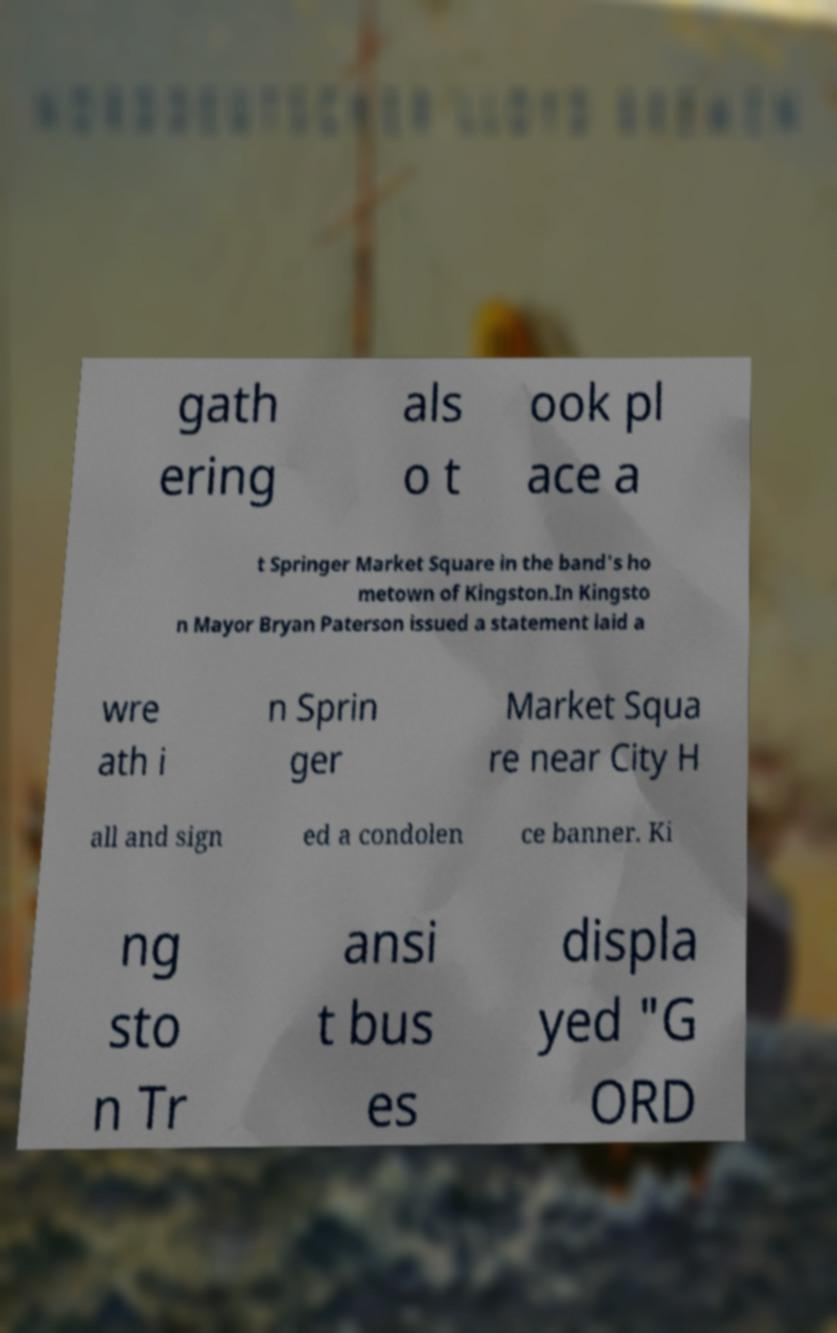Could you extract and type out the text from this image? gath ering als o t ook pl ace a t Springer Market Square in the band's ho metown of Kingston.In Kingsto n Mayor Bryan Paterson issued a statement laid a wre ath i n Sprin ger Market Squa re near City H all and sign ed a condolen ce banner. Ki ng sto n Tr ansi t bus es displa yed "G ORD 